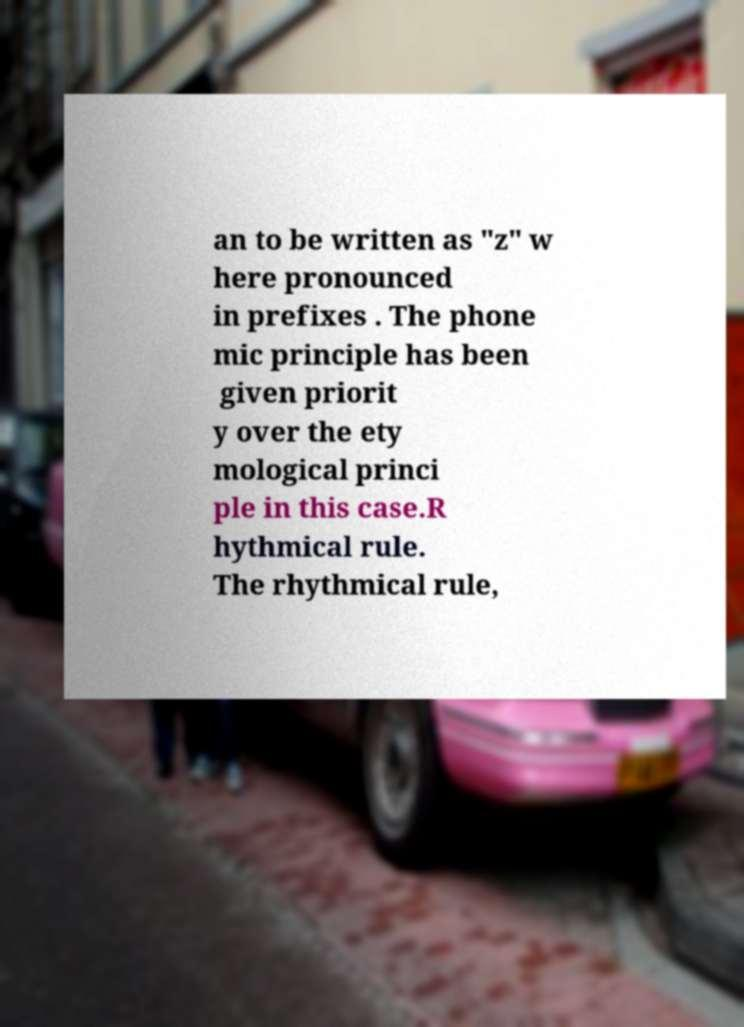Can you accurately transcribe the text from the provided image for me? an to be written as "z" w here pronounced in prefixes . The phone mic principle has been given priorit y over the ety mological princi ple in this case.R hythmical rule. The rhythmical rule, 